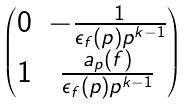Convert formula to latex. <formula><loc_0><loc_0><loc_500><loc_500>\begin{pmatrix} 0 & - \frac { 1 } { \epsilon _ { f } ( p ) p ^ { k - 1 } } \\ 1 & \frac { a _ { p } ( f ) } { \epsilon _ { f } ( p ) p ^ { k - 1 } } \end{pmatrix}</formula> 